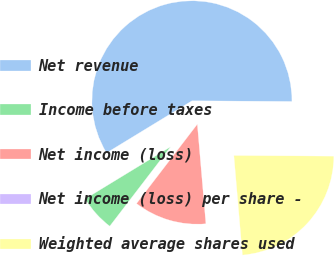Convert chart to OTSL. <chart><loc_0><loc_0><loc_500><loc_500><pie_chart><fcel>Net revenue<fcel>Income before taxes<fcel>Net income (loss)<fcel>Net income (loss) per share -<fcel>Weighted average shares used<nl><fcel>58.82%<fcel>5.88%<fcel>11.77%<fcel>0.0%<fcel>23.53%<nl></chart> 